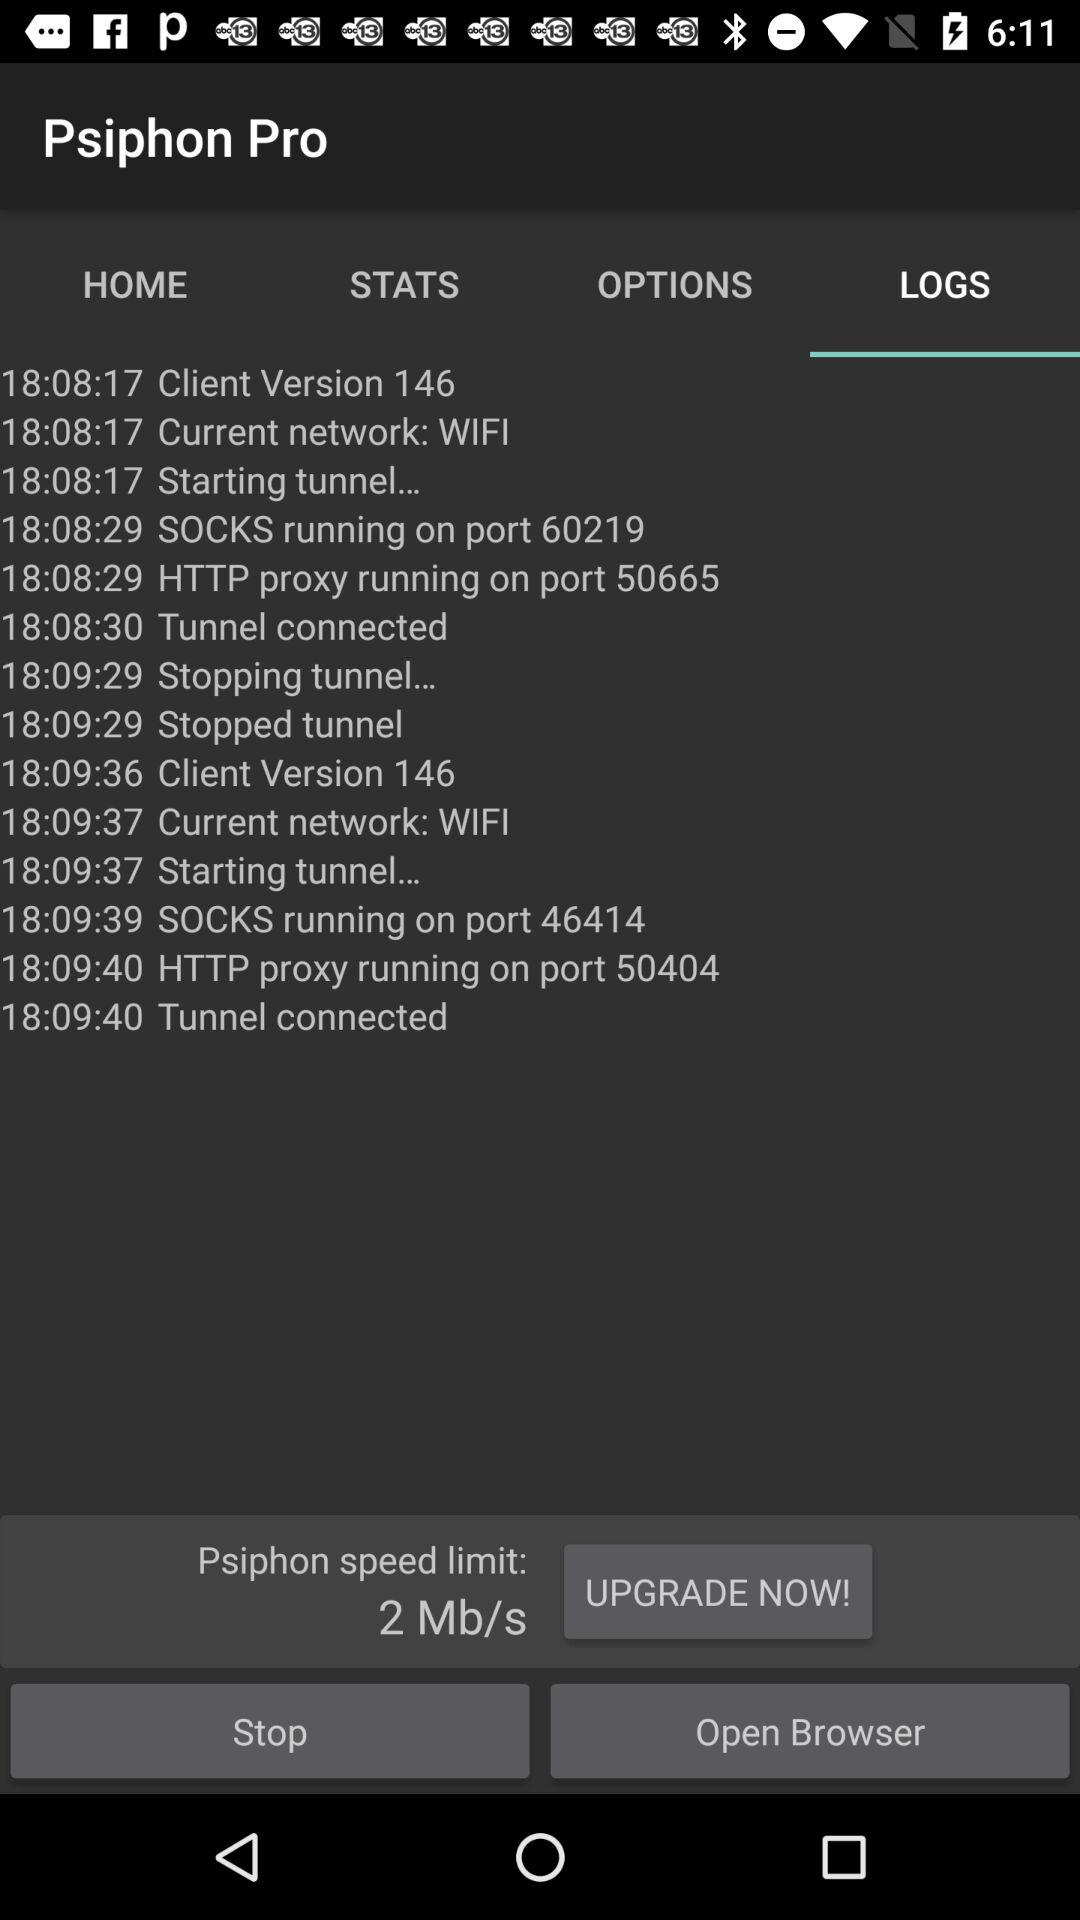Which port is SOCKS running on? SOCKS is running on ports 60219 and 46414. 